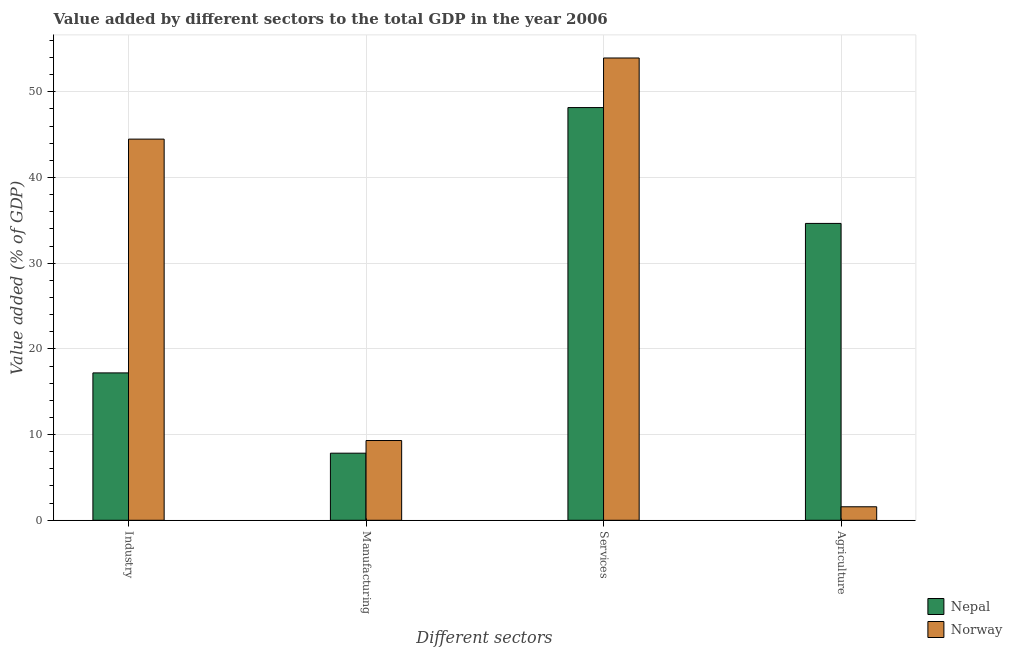How many groups of bars are there?
Your response must be concise. 4. Are the number of bars per tick equal to the number of legend labels?
Provide a short and direct response. Yes. How many bars are there on the 1st tick from the right?
Offer a terse response. 2. What is the label of the 1st group of bars from the left?
Provide a succinct answer. Industry. What is the value added by industrial sector in Norway?
Keep it short and to the point. 44.48. Across all countries, what is the maximum value added by manufacturing sector?
Offer a terse response. 9.31. Across all countries, what is the minimum value added by industrial sector?
Offer a very short reply. 17.2. In which country was the value added by services sector maximum?
Provide a succinct answer. Norway. In which country was the value added by services sector minimum?
Ensure brevity in your answer.  Nepal. What is the total value added by agricultural sector in the graph?
Give a very brief answer. 36.22. What is the difference between the value added by industrial sector in Norway and that in Nepal?
Ensure brevity in your answer.  27.28. What is the difference between the value added by services sector in Nepal and the value added by manufacturing sector in Norway?
Make the answer very short. 38.85. What is the average value added by industrial sector per country?
Your answer should be very brief. 30.84. What is the difference between the value added by services sector and value added by manufacturing sector in Nepal?
Keep it short and to the point. 40.33. In how many countries, is the value added by agricultural sector greater than 44 %?
Make the answer very short. 0. What is the ratio of the value added by industrial sector in Norway to that in Nepal?
Offer a very short reply. 2.59. Is the value added by industrial sector in Norway less than that in Nepal?
Your answer should be very brief. No. What is the difference between the highest and the second highest value added by agricultural sector?
Provide a short and direct response. 33.07. What is the difference between the highest and the lowest value added by industrial sector?
Provide a short and direct response. 27.28. In how many countries, is the value added by industrial sector greater than the average value added by industrial sector taken over all countries?
Your answer should be very brief. 1. What does the 1st bar from the left in Agriculture represents?
Your response must be concise. Nepal. What does the 1st bar from the right in Manufacturing represents?
Make the answer very short. Norway. Is it the case that in every country, the sum of the value added by industrial sector and value added by manufacturing sector is greater than the value added by services sector?
Offer a very short reply. No. How many bars are there?
Your response must be concise. 8. What is the difference between two consecutive major ticks on the Y-axis?
Offer a terse response. 10. Does the graph contain any zero values?
Give a very brief answer. No. Where does the legend appear in the graph?
Your response must be concise. Bottom right. How many legend labels are there?
Provide a succinct answer. 2. How are the legend labels stacked?
Keep it short and to the point. Vertical. What is the title of the graph?
Provide a short and direct response. Value added by different sectors to the total GDP in the year 2006. What is the label or title of the X-axis?
Offer a very short reply. Different sectors. What is the label or title of the Y-axis?
Offer a very short reply. Value added (% of GDP). What is the Value added (% of GDP) of Nepal in Industry?
Make the answer very short. 17.2. What is the Value added (% of GDP) of Norway in Industry?
Give a very brief answer. 44.48. What is the Value added (% of GDP) in Nepal in Manufacturing?
Ensure brevity in your answer.  7.83. What is the Value added (% of GDP) in Norway in Manufacturing?
Offer a terse response. 9.31. What is the Value added (% of GDP) in Nepal in Services?
Your response must be concise. 48.16. What is the Value added (% of GDP) of Norway in Services?
Your answer should be very brief. 53.95. What is the Value added (% of GDP) of Nepal in Agriculture?
Offer a terse response. 34.64. What is the Value added (% of GDP) in Norway in Agriculture?
Provide a short and direct response. 1.57. Across all Different sectors, what is the maximum Value added (% of GDP) of Nepal?
Offer a terse response. 48.16. Across all Different sectors, what is the maximum Value added (% of GDP) in Norway?
Provide a succinct answer. 53.95. Across all Different sectors, what is the minimum Value added (% of GDP) in Nepal?
Ensure brevity in your answer.  7.83. Across all Different sectors, what is the minimum Value added (% of GDP) of Norway?
Keep it short and to the point. 1.57. What is the total Value added (% of GDP) of Nepal in the graph?
Offer a very short reply. 107.83. What is the total Value added (% of GDP) in Norway in the graph?
Your answer should be very brief. 109.31. What is the difference between the Value added (% of GDP) in Nepal in Industry and that in Manufacturing?
Provide a short and direct response. 9.37. What is the difference between the Value added (% of GDP) of Norway in Industry and that in Manufacturing?
Provide a short and direct response. 35.17. What is the difference between the Value added (% of GDP) of Nepal in Industry and that in Services?
Offer a very short reply. -30.96. What is the difference between the Value added (% of GDP) in Norway in Industry and that in Services?
Your answer should be very brief. -9.47. What is the difference between the Value added (% of GDP) in Nepal in Industry and that in Agriculture?
Give a very brief answer. -17.44. What is the difference between the Value added (% of GDP) of Norway in Industry and that in Agriculture?
Make the answer very short. 42.9. What is the difference between the Value added (% of GDP) of Nepal in Manufacturing and that in Services?
Ensure brevity in your answer.  -40.33. What is the difference between the Value added (% of GDP) in Norway in Manufacturing and that in Services?
Your answer should be compact. -44.64. What is the difference between the Value added (% of GDP) of Nepal in Manufacturing and that in Agriculture?
Keep it short and to the point. -26.81. What is the difference between the Value added (% of GDP) of Norway in Manufacturing and that in Agriculture?
Offer a very short reply. 7.73. What is the difference between the Value added (% of GDP) in Nepal in Services and that in Agriculture?
Give a very brief answer. 13.52. What is the difference between the Value added (% of GDP) of Norway in Services and that in Agriculture?
Give a very brief answer. 52.37. What is the difference between the Value added (% of GDP) of Nepal in Industry and the Value added (% of GDP) of Norway in Manufacturing?
Offer a very short reply. 7.89. What is the difference between the Value added (% of GDP) of Nepal in Industry and the Value added (% of GDP) of Norway in Services?
Keep it short and to the point. -36.75. What is the difference between the Value added (% of GDP) of Nepal in Industry and the Value added (% of GDP) of Norway in Agriculture?
Offer a terse response. 15.62. What is the difference between the Value added (% of GDP) in Nepal in Manufacturing and the Value added (% of GDP) in Norway in Services?
Your answer should be very brief. -46.12. What is the difference between the Value added (% of GDP) in Nepal in Manufacturing and the Value added (% of GDP) in Norway in Agriculture?
Ensure brevity in your answer.  6.25. What is the difference between the Value added (% of GDP) in Nepal in Services and the Value added (% of GDP) in Norway in Agriculture?
Make the answer very short. 46.59. What is the average Value added (% of GDP) in Nepal per Different sectors?
Your response must be concise. 26.96. What is the average Value added (% of GDP) of Norway per Different sectors?
Ensure brevity in your answer.  27.33. What is the difference between the Value added (% of GDP) of Nepal and Value added (% of GDP) of Norway in Industry?
Provide a short and direct response. -27.28. What is the difference between the Value added (% of GDP) in Nepal and Value added (% of GDP) in Norway in Manufacturing?
Keep it short and to the point. -1.48. What is the difference between the Value added (% of GDP) of Nepal and Value added (% of GDP) of Norway in Services?
Provide a succinct answer. -5.79. What is the difference between the Value added (% of GDP) of Nepal and Value added (% of GDP) of Norway in Agriculture?
Provide a succinct answer. 33.07. What is the ratio of the Value added (% of GDP) in Nepal in Industry to that in Manufacturing?
Offer a very short reply. 2.2. What is the ratio of the Value added (% of GDP) of Norway in Industry to that in Manufacturing?
Give a very brief answer. 4.78. What is the ratio of the Value added (% of GDP) of Nepal in Industry to that in Services?
Make the answer very short. 0.36. What is the ratio of the Value added (% of GDP) of Norway in Industry to that in Services?
Your answer should be very brief. 0.82. What is the ratio of the Value added (% of GDP) in Nepal in Industry to that in Agriculture?
Offer a very short reply. 0.5. What is the ratio of the Value added (% of GDP) of Norway in Industry to that in Agriculture?
Make the answer very short. 28.24. What is the ratio of the Value added (% of GDP) of Nepal in Manufacturing to that in Services?
Give a very brief answer. 0.16. What is the ratio of the Value added (% of GDP) in Norway in Manufacturing to that in Services?
Ensure brevity in your answer.  0.17. What is the ratio of the Value added (% of GDP) in Nepal in Manufacturing to that in Agriculture?
Give a very brief answer. 0.23. What is the ratio of the Value added (% of GDP) of Norway in Manufacturing to that in Agriculture?
Make the answer very short. 5.91. What is the ratio of the Value added (% of GDP) of Nepal in Services to that in Agriculture?
Ensure brevity in your answer.  1.39. What is the ratio of the Value added (% of GDP) of Norway in Services to that in Agriculture?
Provide a succinct answer. 34.25. What is the difference between the highest and the second highest Value added (% of GDP) in Nepal?
Give a very brief answer. 13.52. What is the difference between the highest and the second highest Value added (% of GDP) of Norway?
Your answer should be compact. 9.47. What is the difference between the highest and the lowest Value added (% of GDP) of Nepal?
Provide a short and direct response. 40.33. What is the difference between the highest and the lowest Value added (% of GDP) of Norway?
Give a very brief answer. 52.37. 